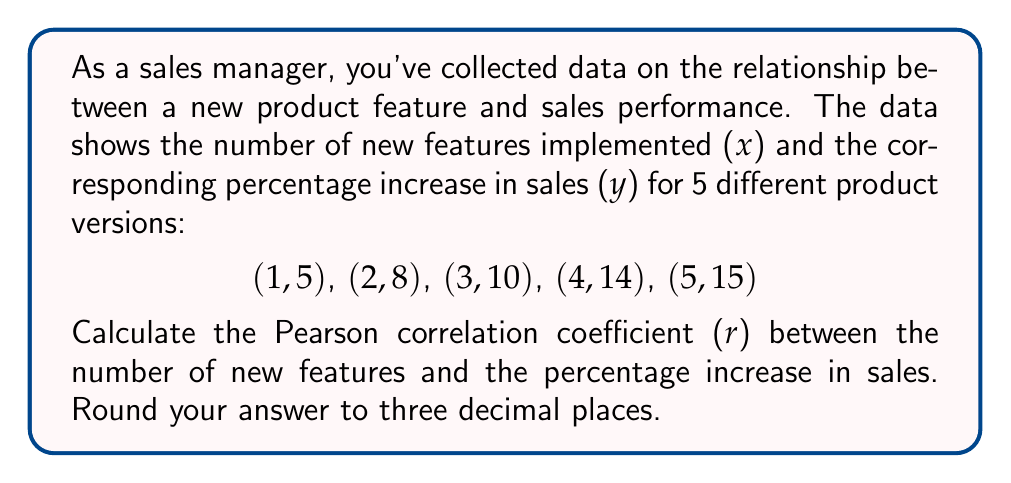Can you answer this question? To calculate the Pearson correlation coefficient (r), we'll use the formula:

$$ r = \frac{n\sum xy - \sum x \sum y}{\sqrt{[n\sum x^2 - (\sum x)^2][n\sum y^2 - (\sum y)^2]}} $$

Where:
n = number of data points
x = number of new features
y = percentage increase in sales

Step 1: Calculate the required sums:
n = 5
$\sum x = 1 + 2 + 3 + 4 + 5 = 15$
$\sum y = 5 + 8 + 10 + 14 + 15 = 52$
$\sum xy = (1)(5) + (2)(8) + (3)(10) + (4)(14) + (5)(15) = 5 + 16 + 30 + 56 + 75 = 182$
$\sum x^2 = 1^2 + 2^2 + 3^2 + 4^2 + 5^2 = 1 + 4 + 9 + 16 + 25 = 55$
$\sum y^2 = 5^2 + 8^2 + 10^2 + 14^2 + 15^2 = 25 + 64 + 100 + 196 + 225 = 610$

Step 2: Apply the formula:

$$ r = \frac{5(182) - (15)(52)}{\sqrt{[5(55) - (15)^2][5(610) - (52)^2]}} $$

$$ r = \frac{910 - 780}{\sqrt{(275 - 225)(3050 - 2704)}} $$

$$ r = \frac{130}{\sqrt{(50)(346)}} $$

$$ r = \frac{130}{\sqrt{17300}} $$

$$ r = \frac{130}{131.529} $$

$$ r \approx 0.988 $$

Therefore, the Pearson correlation coefficient (r) rounded to three decimal places is 0.988.
Answer: 0.988 